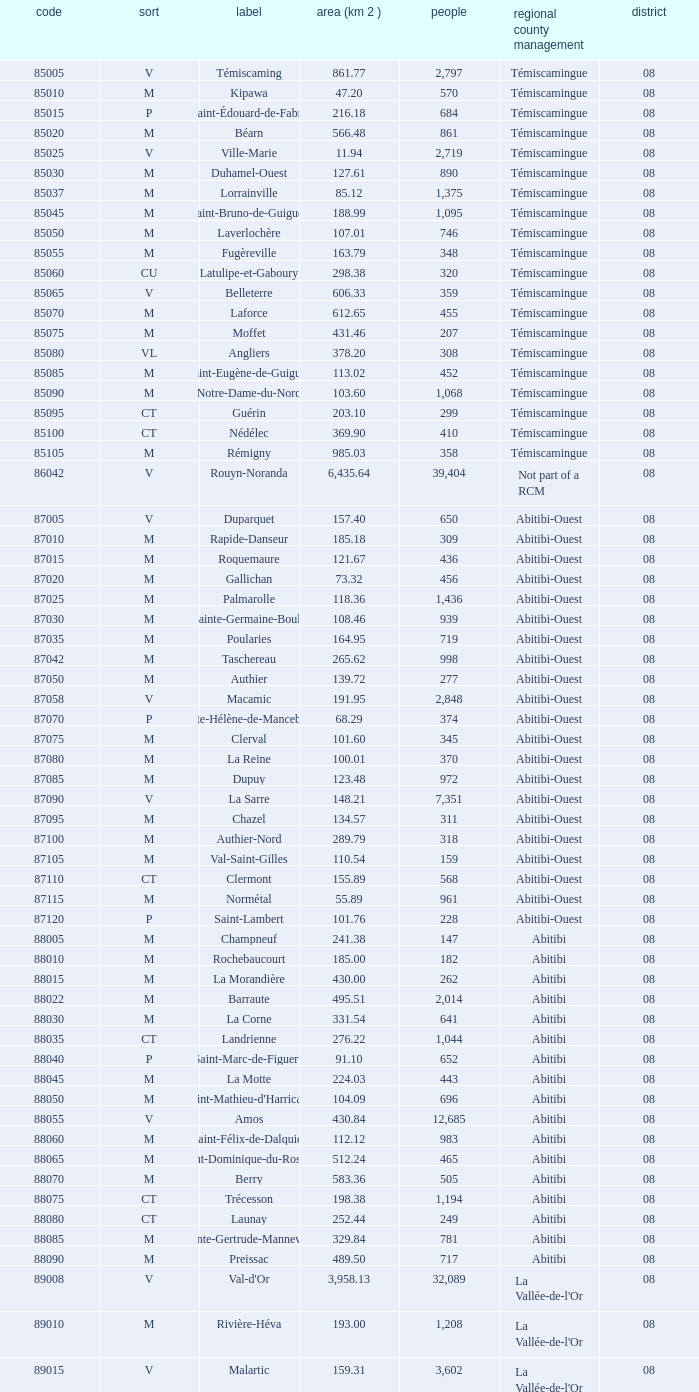What is Dupuy lowest area in km2? 123.48. 